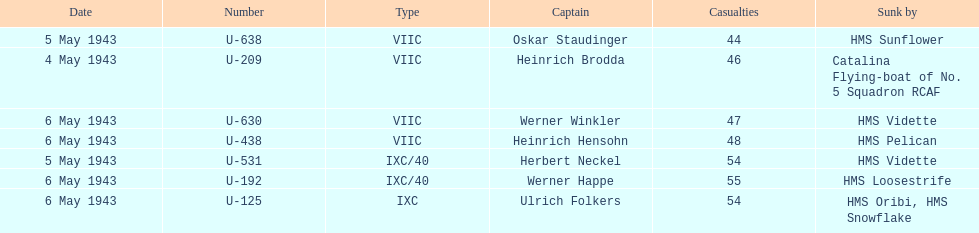Which u-boat was the first to sink U-209. 